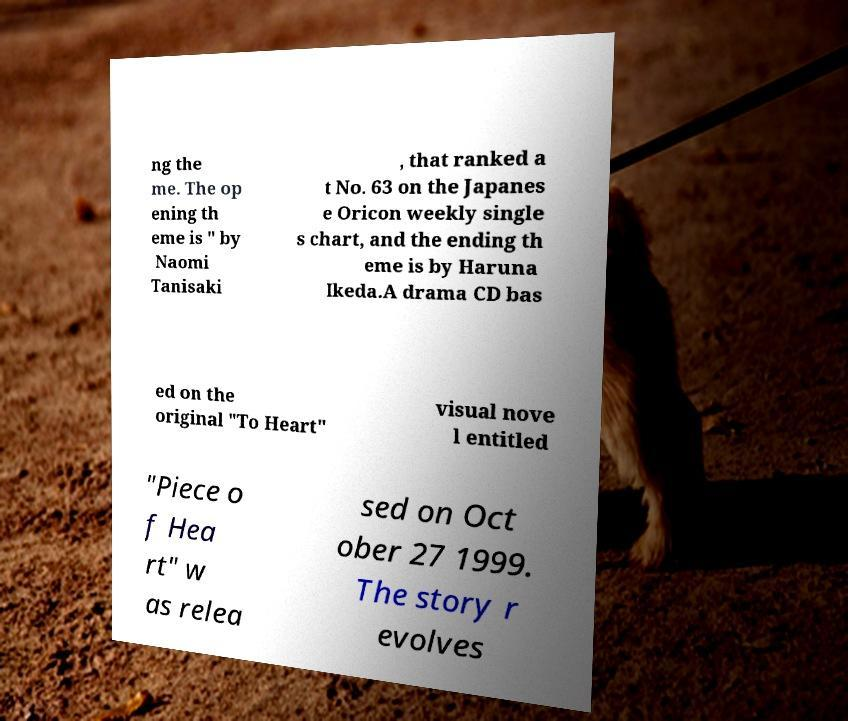Can you read and provide the text displayed in the image?This photo seems to have some interesting text. Can you extract and type it out for me? ng the me. The op ening th eme is " by Naomi Tanisaki , that ranked a t No. 63 on the Japanes e Oricon weekly single s chart, and the ending th eme is by Haruna Ikeda.A drama CD bas ed on the original "To Heart" visual nove l entitled "Piece o f Hea rt" w as relea sed on Oct ober 27 1999. The story r evolves 